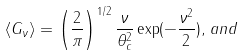Convert formula to latex. <formula><loc_0><loc_0><loc_500><loc_500>\langle G _ { \nu } \rangle = \left ( \frac { 2 } { \pi } \right ) ^ { 1 / 2 } \frac { \nu } { \theta _ { c } ^ { 2 } } \exp ( - \frac { \nu ^ { 2 } } { 2 } ) , \, a n d</formula> 